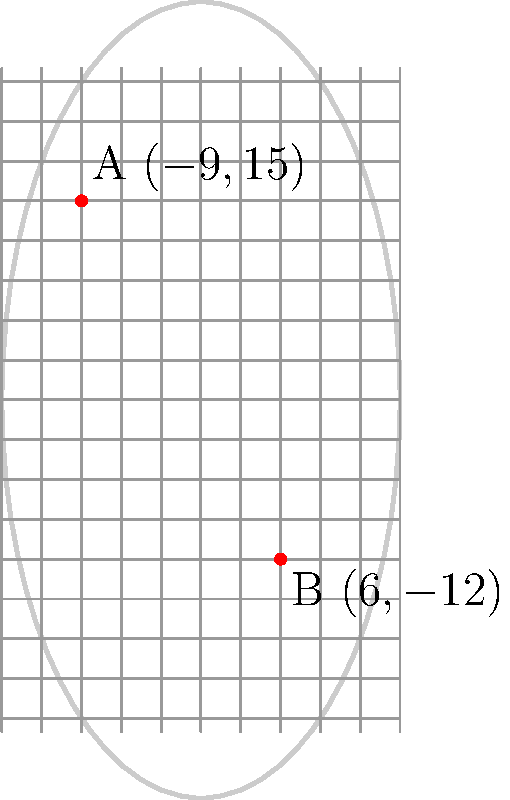As a rising tennis star, you're analyzing the string bed of your racket. Two points on the string bed, A $(-9,15)$ and B $(6,-12)$, catch your attention. Find the equation of the line passing through these two points in slope-intercept form $(y = mx + b)$. This could help you understand the angle of your shots and improve your game strategy. Let's approach this step-by-step:

1) To find the equation of a line, we need to calculate the slope (m) and y-intercept (b).

2) First, let's calculate the slope using the slope formula:
   $m = \frac{y_2 - y_1}{x_2 - x_1} = \frac{-12 - 15}{6 - (-9)} = \frac{-27}{15} = -\frac{9}{5} = -1.8$

3) Now that we have the slope, we can use the point-slope form of a line equation:
   $y - y_1 = m(x - x_1)$

4) Let's use point A $(-9,15)$:
   $y - 15 = -\frac{9}{5}(x - (-9))$
   $y - 15 = -\frac{9}{5}(x + 9)$

5) Distribute the slope:
   $y - 15 = -\frac{9}{5}x - \frac{81}{5}$

6) Add 15 to both sides:
   $y = -\frac{9}{5}x - \frac{81}{5} + 15$

7) Simplify:
   $y = -\frac{9}{5}x - \frac{81}{5} + \frac{75}{5} = -\frac{9}{5}x - \frac{6}{5}$

8) Therefore, the equation in slope-intercept form is:
   $y = -\frac{9}{5}x - \frac{6}{5}$

This equation represents the line passing through the two points on your racket's string bed.
Answer: $y = -\frac{9}{5}x - \frac{6}{5}$ 